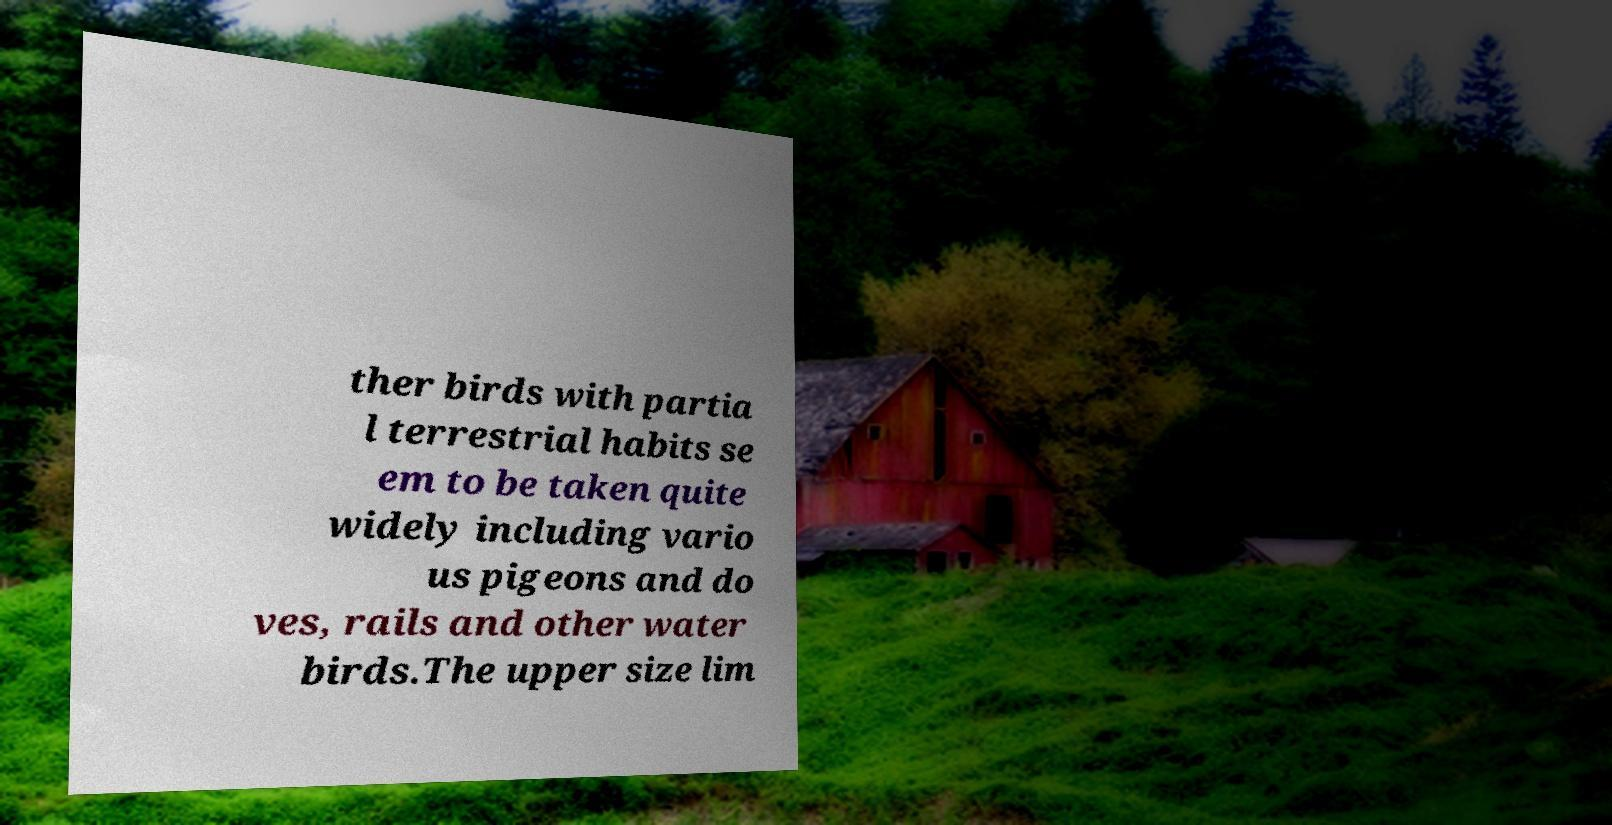I need the written content from this picture converted into text. Can you do that? ther birds with partia l terrestrial habits se em to be taken quite widely including vario us pigeons and do ves, rails and other water birds.The upper size lim 